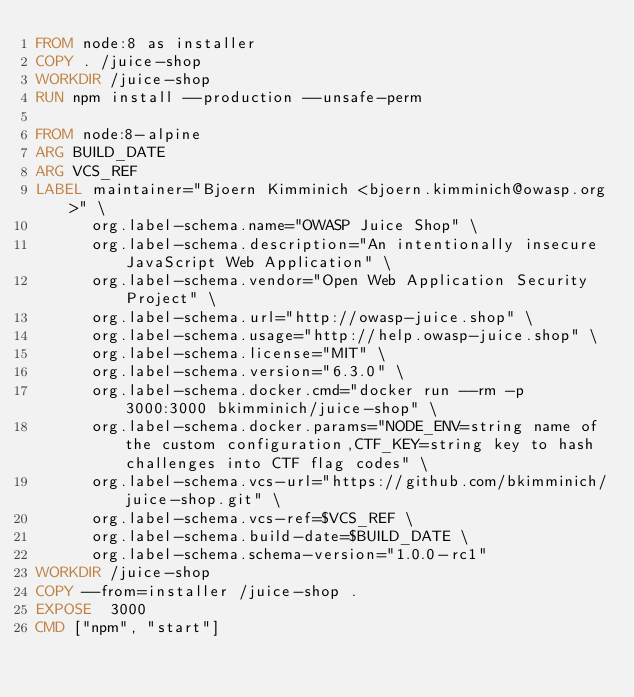<code> <loc_0><loc_0><loc_500><loc_500><_Dockerfile_>FROM node:8 as installer
COPY . /juice-shop
WORKDIR /juice-shop
RUN npm install --production --unsafe-perm

FROM node:8-alpine
ARG BUILD_DATE
ARG VCS_REF
LABEL maintainer="Bjoern Kimminich <bjoern.kimminich@owasp.org>" \
      org.label-schema.name="OWASP Juice Shop" \
      org.label-schema.description="An intentionally insecure JavaScript Web Application" \
      org.label-schema.vendor="Open Web Application Security Project" \
      org.label-schema.url="http://owasp-juice.shop" \
      org.label-schema.usage="http://help.owasp-juice.shop" \
      org.label-schema.license="MIT" \
      org.label-schema.version="6.3.0" \
      org.label-schema.docker.cmd="docker run --rm -p 3000:3000 bkimminich/juice-shop" \
      org.label-schema.docker.params="NODE_ENV=string name of the custom configuration,CTF_KEY=string key to hash challenges into CTF flag codes" \
      org.label-schema.vcs-url="https://github.com/bkimminich/juice-shop.git" \
      org.label-schema.vcs-ref=$VCS_REF \
      org.label-schema.build-date=$BUILD_DATE \
      org.label-schema.schema-version="1.0.0-rc1"
WORKDIR /juice-shop
COPY --from=installer /juice-shop .
EXPOSE  3000
CMD ["npm", "start"]</code> 